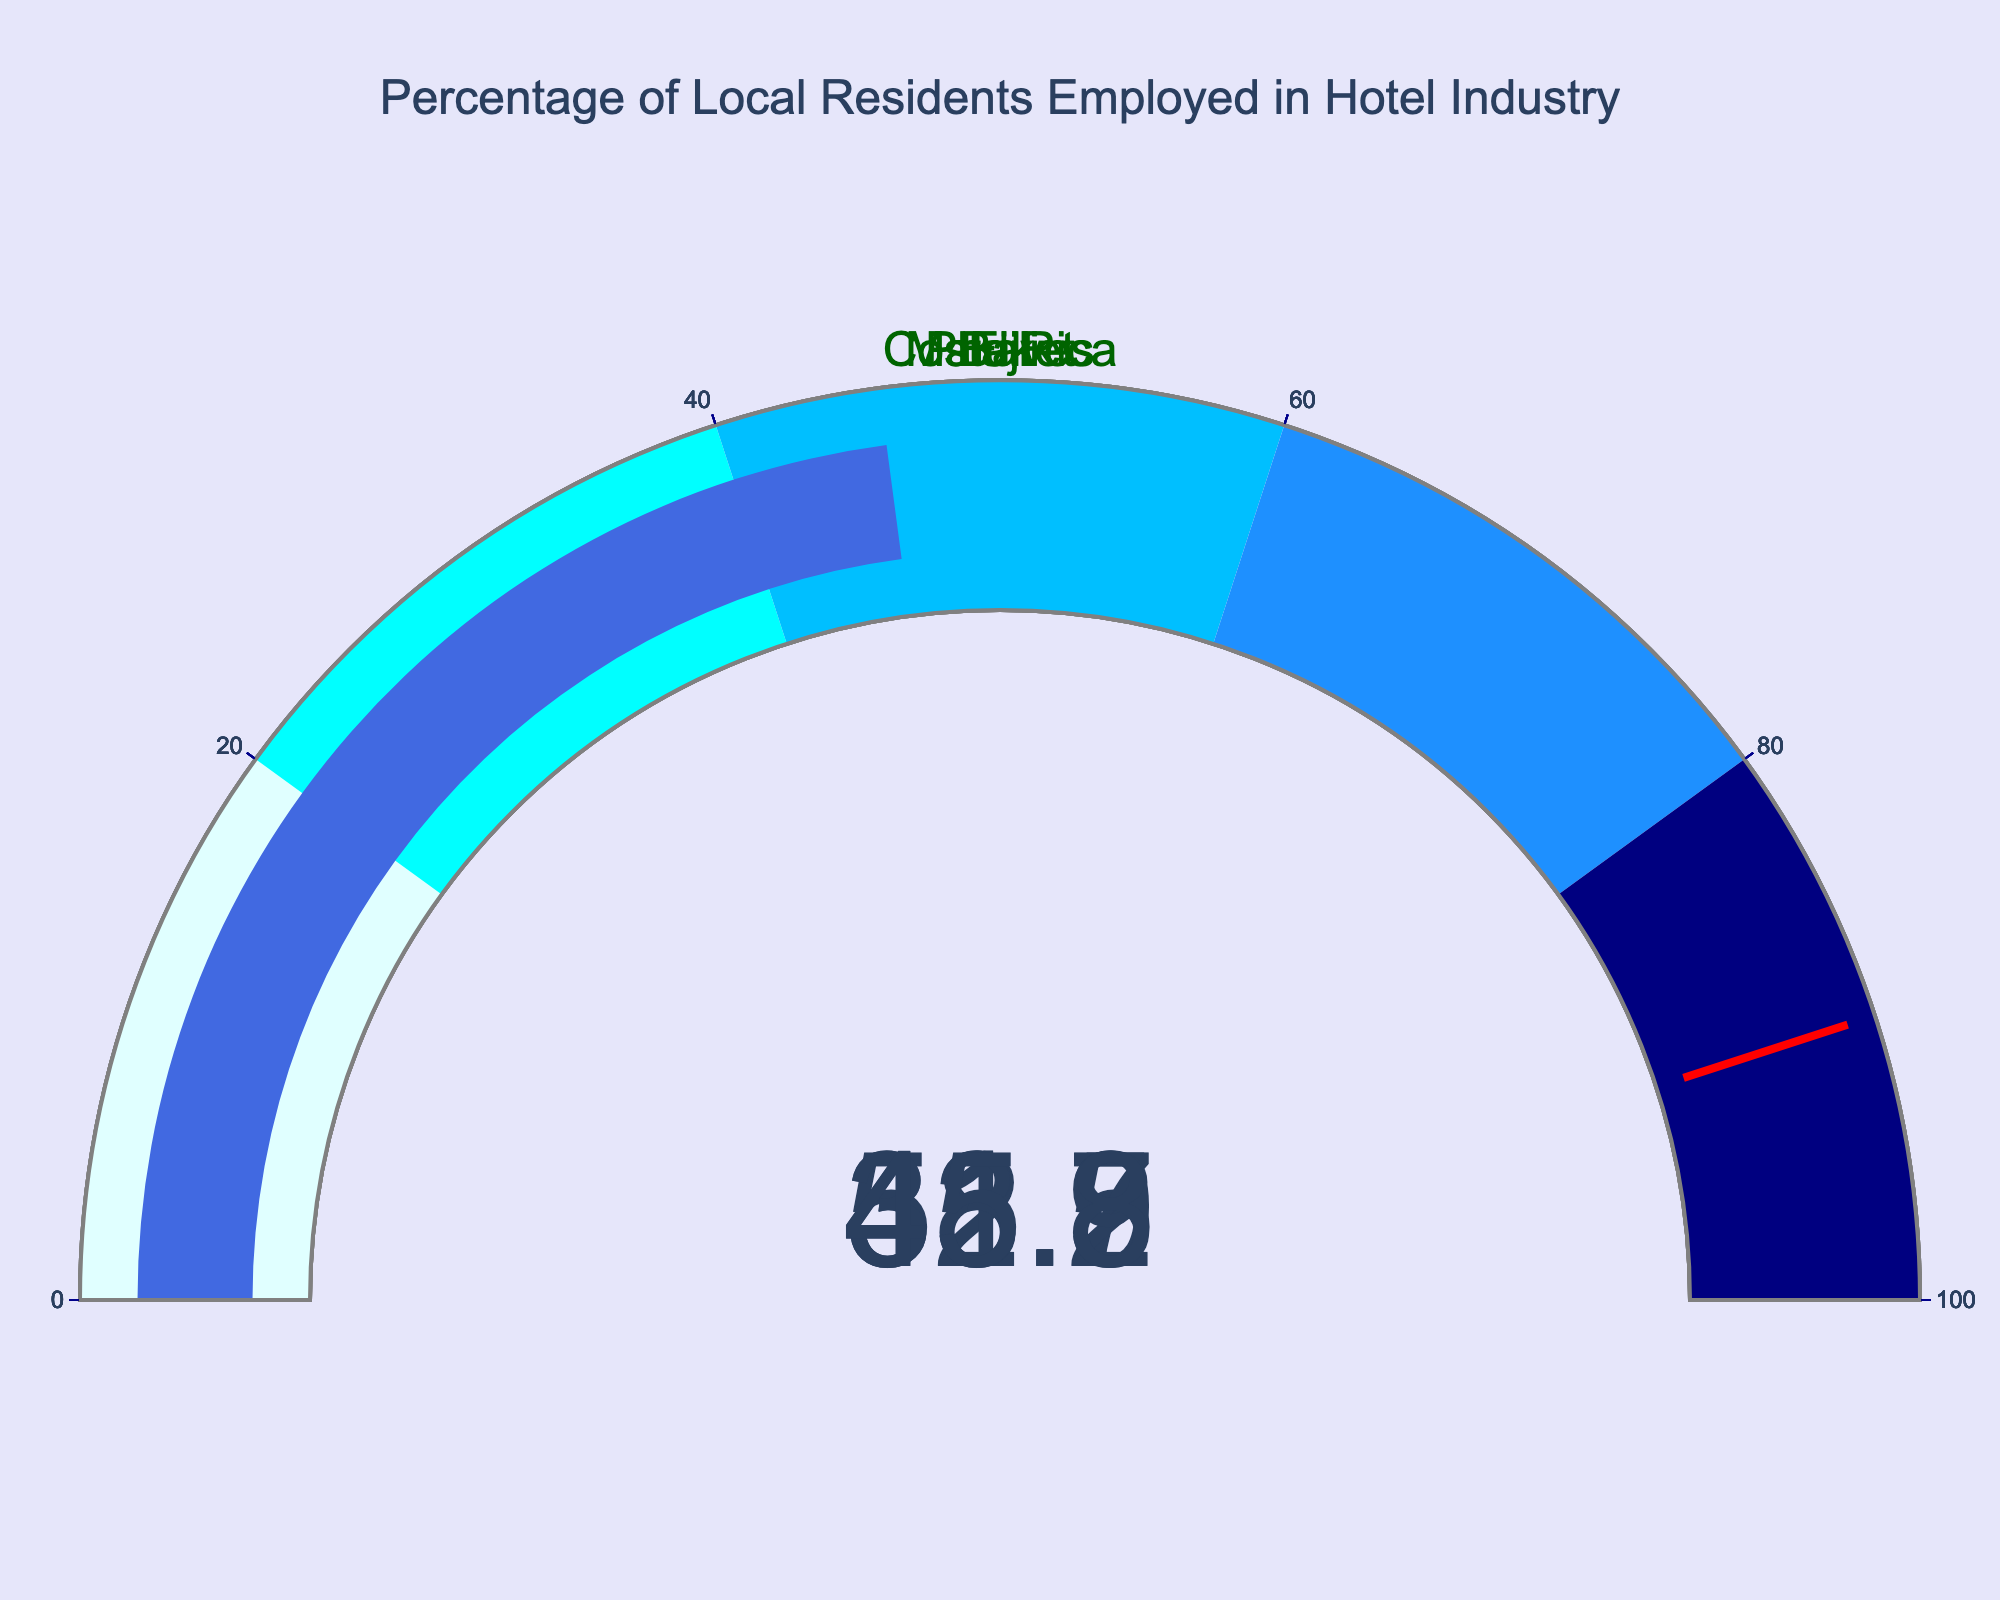what is the percentage of local residents employed in Bali? The gauge chart for Bali shows a single number representing the percentage of local residents employed in the hotel industry.
Answer: 42.5% which region has the highest percentage of local residents employed in the hotel industry? Comparing the values displayed on all the gauge charts, Maldives has the highest percentage.
Answer: Maldives what is the difference in employment percentages between Phuket and Costa Rica? Look at the percentages for Phuket (38.7%) and Costa Rica (33.9%). Subtract the latter from the former.
Answer: 4.8% how many regions have an employment percentage greater than 40%? Look at the values displayed. Bali (42.5%), Maldives (51.2%), and Fiji (45.8%) are greater than 40%. Count these regions.
Answer: 3 which regions have a percentage less than 35%? Look at the values displayed. Only Costa Rica has a percentage less than 35% (33.9%).
Answer: Costa Rica what is the average percentage of local residents employed across all regions? Sum the percentages of all regions (42.5 + 38.7 + 51.2 + 33.9 + 45.8) and divide by the number of regions (5).
Answer: 42.42% considering regions with employment percentages above 40%, what is their average percentage? Sum the percentages of Bali (42.5%), Maldives (51.2%), and Fiji (45.8%) and divide by 3, because those are the regions above 40%.
Answer: 46.5% 